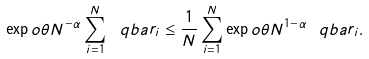<formula> <loc_0><loc_0><loc_500><loc_500>\exp o { \theta N ^ { - \alpha } \sum _ { i = 1 } ^ { N } \ q b a r _ { i } } \leq \frac { 1 } { N } \sum _ { i = 1 } ^ { N } \exp o { \theta N ^ { 1 - \alpha } \ q b a r _ { i } } .</formula> 